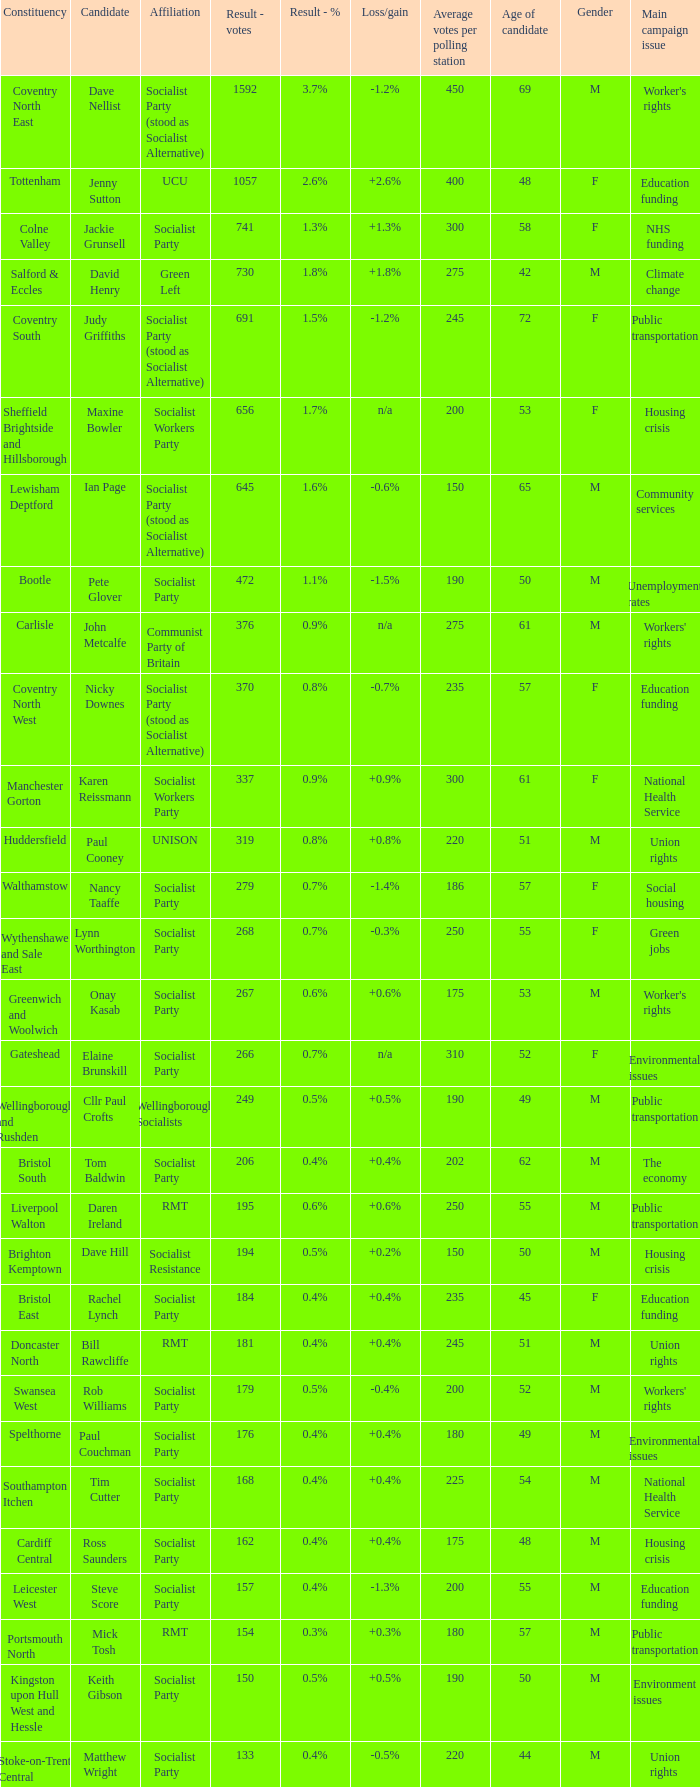What is the largest vote result for the Huddersfield constituency? 319.0. Can you parse all the data within this table? {'header': ['Constituency', 'Candidate', 'Affiliation', 'Result - votes', 'Result - %', 'Loss/gain', 'Average votes per polling station', 'Age of candidate', 'Gender', 'Main campaign issue'], 'rows': [['Coventry North East', 'Dave Nellist', 'Socialist Party (stood as Socialist Alternative)', '1592', '3.7%', '-1.2%', '450', '69', 'M', "Worker's rights"], ['Tottenham', 'Jenny Sutton', 'UCU', '1057', '2.6%', '+2.6%', '400', '48', 'F', 'Education funding'], ['Colne Valley', 'Jackie Grunsell', 'Socialist Party', '741', '1.3%', '+1.3%', '300', '58', 'F', 'NHS funding'], ['Salford & Eccles', 'David Henry', 'Green Left', '730', '1.8%', '+1.8%', '275', '42', 'M', 'Climate change'], ['Coventry South', 'Judy Griffiths', 'Socialist Party (stood as Socialist Alternative)', '691', '1.5%', '-1.2%', '245', '72', 'F', 'Public transportation'], ['Sheffield Brightside and Hillsborough', 'Maxine Bowler', 'Socialist Workers Party', '656', '1.7%', 'n/a', '200', '53', 'F', 'Housing crisis'], ['Lewisham Deptford', 'Ian Page', 'Socialist Party (stood as Socialist Alternative)', '645', '1.6%', '-0.6%', '150', '65', 'M', 'Community services'], ['Bootle', 'Pete Glover', 'Socialist Party', '472', '1.1%', '-1.5%', '190', '50', 'M', 'Unemployment rates'], ['Carlisle', 'John Metcalfe', 'Communist Party of Britain', '376', '0.9%', 'n/a', '275', '61', 'M', "Workers' rights"], ['Coventry North West', 'Nicky Downes', 'Socialist Party (stood as Socialist Alternative)', '370', '0.8%', '-0.7%', '235', '57', 'F', 'Education funding'], ['Manchester Gorton', 'Karen Reissmann', 'Socialist Workers Party', '337', '0.9%', '+0.9%', '300', '61', 'F', 'National Health Service'], ['Huddersfield', 'Paul Cooney', 'UNISON', '319', '0.8%', '+0.8%', '220', '51', 'M', 'Union rights'], ['Walthamstow', 'Nancy Taaffe', 'Socialist Party', '279', '0.7%', '-1.4%', '186', '57', 'F', 'Social housing'], ['Wythenshawe and Sale East', 'Lynn Worthington', 'Socialist Party', '268', '0.7%', '-0.3%', '250', '55', 'F', 'Green jobs'], ['Greenwich and Woolwich', 'Onay Kasab', 'Socialist Party', '267', '0.6%', '+0.6%', '175', '53', 'M', "Worker's rights"], ['Gateshead', 'Elaine Brunskill', 'Socialist Party', '266', '0.7%', 'n/a', '310', '52', 'F', 'Environmental issues'], ['Wellingborough and Rushden', 'Cllr Paul Crofts', 'Wellingborough Socialists', '249', '0.5%', '+0.5%', '190', '49', 'M', 'Public transportation'], ['Bristol South', 'Tom Baldwin', 'Socialist Party', '206', '0.4%', '+0.4%', '202', '62', 'M', 'The economy'], ['Liverpool Walton', 'Daren Ireland', 'RMT', '195', '0.6%', '+0.6%', '250', '55', 'M', 'Public transportation'], ['Brighton Kemptown', 'Dave Hill', 'Socialist Resistance', '194', '0.5%', '+0.2%', '150', '50', 'M', 'Housing crisis'], ['Bristol East', 'Rachel Lynch', 'Socialist Party', '184', '0.4%', '+0.4%', '235', '45', 'F', 'Education funding'], ['Doncaster North', 'Bill Rawcliffe', 'RMT', '181', '0.4%', '+0.4%', '245', '51', 'M', 'Union rights'], ['Swansea West', 'Rob Williams', 'Socialist Party', '179', '0.5%', '-0.4%', '200', '52', 'M', "Workers' rights"], ['Spelthorne', 'Paul Couchman', 'Socialist Party', '176', '0.4%', '+0.4%', '180', '49', 'M', 'Environmental issues'], ['Southampton Itchen', 'Tim Cutter', 'Socialist Party', '168', '0.4%', '+0.4%', '225', '54', 'M', 'National Health Service'], ['Cardiff Central', 'Ross Saunders', 'Socialist Party', '162', '0.4%', '+0.4%', '175', '48', 'M', 'Housing crisis'], ['Leicester West', 'Steve Score', 'Socialist Party', '157', '0.4%', '-1.3%', '200', '55', 'M', 'Education funding'], ['Portsmouth North', 'Mick Tosh', 'RMT', '154', '0.3%', '+0.3%', '180', '57', 'M', 'Public transportation'], ['Kingston upon Hull West and Hessle', 'Keith Gibson', 'Socialist Party', '150', '0.5%', '+0.5%', '190', '50', 'M', 'Environment issues'], ['Stoke-on-Trent Central', 'Matthew Wright', 'Socialist Party', '133', '0.4%', '-0.5%', '220', '44', 'M', 'Union rights']]} 